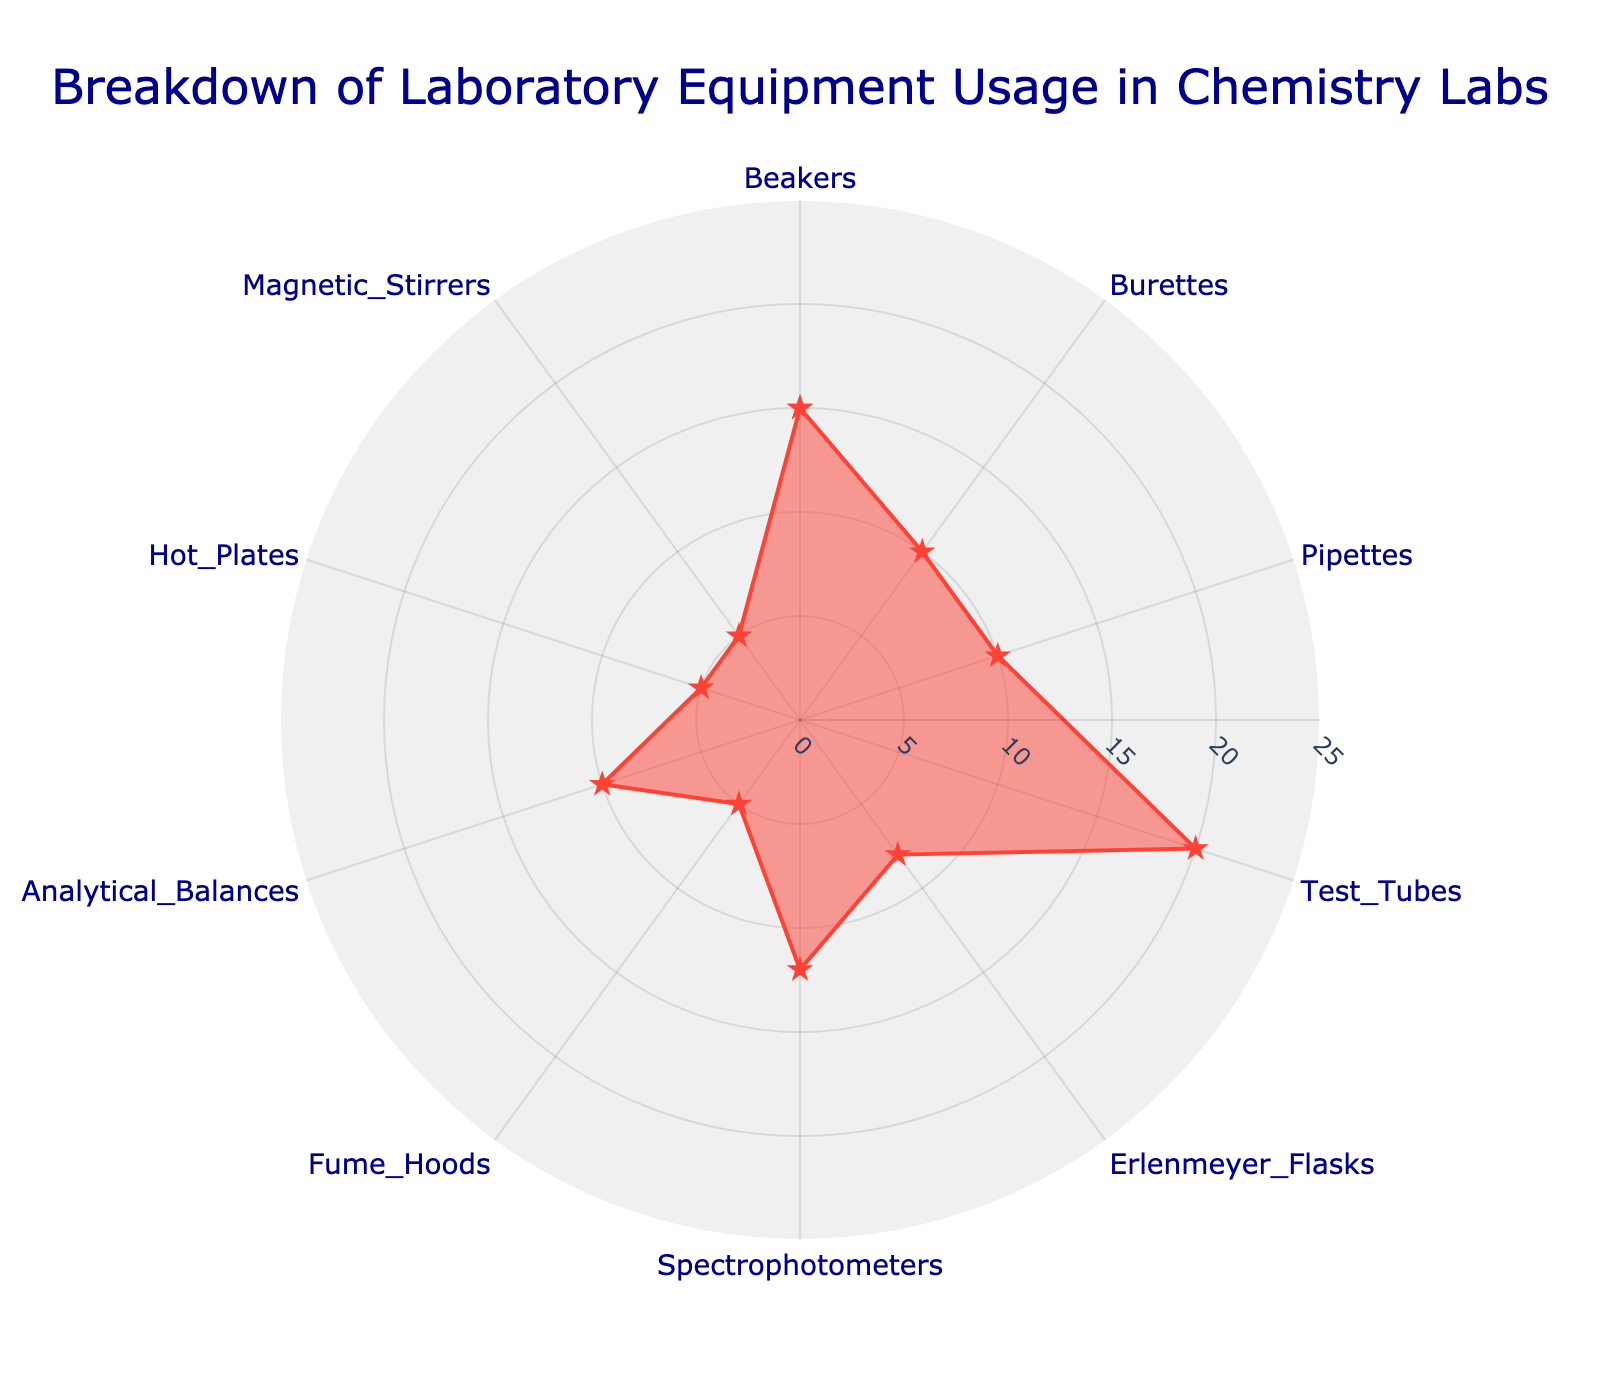What's the title of the radar chart? The title is usually located at the top of the chart and provides a brief description of what the chart represents. In this chart, it is "Breakdown of Laboratory Equipment Usage in Chemistry Labs".
Answer: Breakdown of Laboratory Equipment Usage in Chemistry Labs Which piece of equipment has the highest usage percentage? To find the highest usage percentage, observe the radial lines extending from the center. The longest line corresponds to the highest value. Test Tubes, with 20%, have the longest line.
Answer: Test Tubes What's the combined usage percentage of Burettes and Pipettes? Burettes have 10% and Pipettes also have 10%. Adding these two percentages together gives 10% + 10% = 20%.
Answer: 20% Which equipment has equal usage percentages? By inspecting the lengths of the lines, it is clear that Burettes, Pipettes, and Analytical Balances each have a usage percentage of 10%.
Answer: Burettes, Pipettes, and Analytical Balances Is the usage percentage of Spectrophotometers greater than that of Erlenmeyer Flasks? Spectrophotometers have a usage percentage of 12% compared to Erlenmeyer Flasks' 8%. Since 12% is greater than 8%, the usage is indeed higher.
Answer: Yes Rank the following equipment from highest to lowest usage: Spectrophotometers, Hot Plates, and Magnetic Stirrers. Spectrophotometers are at 12%, Hot Plates at 5%, and Magnetic Stirrers also at 5%. Therefore, the order from highest to lowest is: Spectrophotometers, Hot Plates, Magnetic Stirrers.
Answer: Spectrophotometers, Hot Plates, Magnetic Stirrers What is the average usage percentage of Hot Plates, Fume Hoods, and Magnetic Stirrers? Add the percentages: 5% (Hot Plates) + 5% (Fume Hoods) + 5% (Magnetic Stirrers) = 15%. Divide by the number of equipment (3): 15% / 3 = 5%.
Answer: 5% Among Beakers, Test Tubes, and Spectrophotometers, which has the median usage percentage? Arrange the usage percentages in ascending order: Beakers (15%), Spectrophotometers (12%), Test Tubes (20%). The median value is the middle value, which is 15%.
Answer: Beakers If the highest and lowest usage percentages are removed, what is the new average usage percentage of the remaining equipment? Excluding the highest (Test Tubes, 20%) and lowest (Hot Plates/Magnetic Stirrers/Fume Hoods, 5%), the remaining percentages are: Beakers (15%), Burettes (10%), Pipettes (10%), Erlenmeyer Flasks (8%), Spectrophotometers (12%), and Analytical Balances (10%). Sum these: 15% + 10% + 10% + 8% + 12% + 10% = 65%. Divide by the number of remaining equipment (6): 65% / 6 ≈ 10.83%.
Answer: 10.83% Do Fume Hoods and Magnetic Stirrers have the same usage percentage? By looking at the chart, we see that both Fume Hoods and Magnetic Stirrers have lines extending to the same length of 5%.
Answer: Yes 